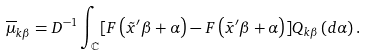<formula> <loc_0><loc_0><loc_500><loc_500>\overline { \mu } _ { k \beta } = D ^ { - 1 } \int _ { \mathbb { C } } [ F \left ( \tilde { x } ^ { \prime } \beta + \alpha \right ) - F \left ( \bar { x } ^ { \prime } \beta + \alpha \right ) ] Q _ { k \beta } \left ( d \alpha \right ) .</formula> 